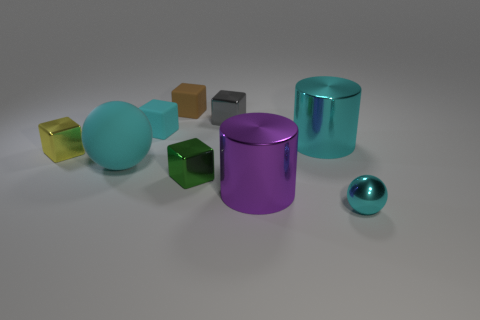What material is the small cyan object behind the rubber object that is in front of the large cyan metallic object?
Provide a short and direct response. Rubber. How many tiny green objects have the same shape as the tiny gray metallic object?
Give a very brief answer. 1. Are there any tiny balls of the same color as the big sphere?
Give a very brief answer. Yes. How many objects are either tiny rubber things that are in front of the small brown matte block or cubes that are on the left side of the gray metal cube?
Provide a short and direct response. 4. There is a cyan metallic thing in front of the large matte object; is there a cyan thing behind it?
Your answer should be compact. Yes. What is the shape of the green thing that is the same size as the brown object?
Provide a short and direct response. Cube. How many objects are either cylinders that are behind the yellow metallic block or tiny blocks?
Make the answer very short. 6. What number of other objects are there of the same material as the green object?
Your answer should be compact. 5. The small object that is the same color as the metallic sphere is what shape?
Offer a terse response. Cube. There is a sphere that is right of the big purple shiny object; what size is it?
Provide a short and direct response. Small. 